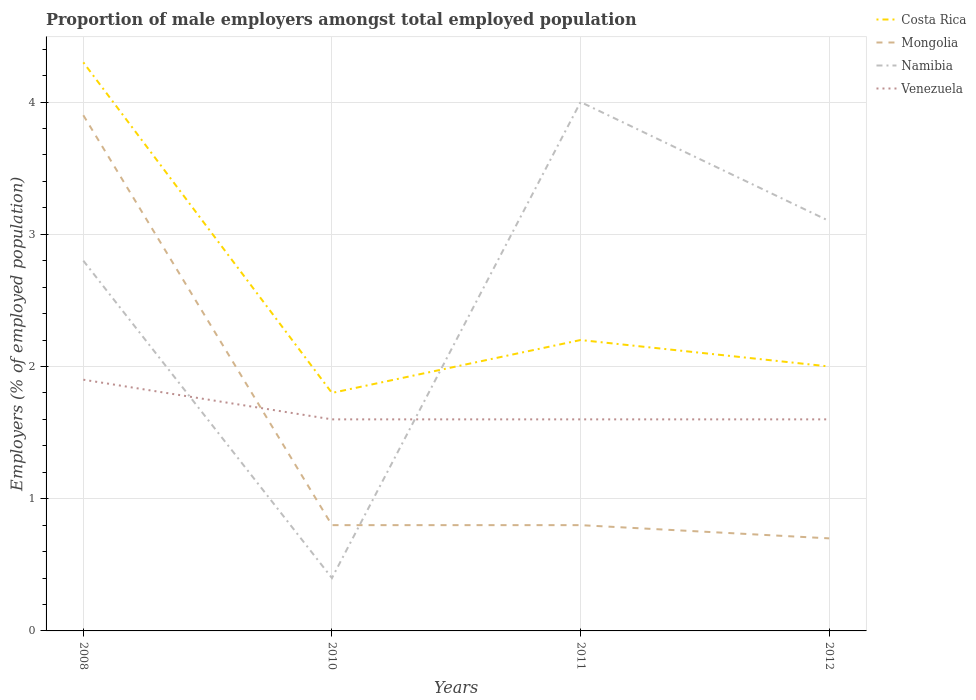Across all years, what is the maximum proportion of male employers in Venezuela?
Keep it short and to the point. 1.6. What is the total proportion of male employers in Costa Rica in the graph?
Provide a short and direct response. -0.4. What is the difference between the highest and the second highest proportion of male employers in Namibia?
Make the answer very short. 3.6. Is the proportion of male employers in Namibia strictly greater than the proportion of male employers in Costa Rica over the years?
Make the answer very short. No. How many lines are there?
Your answer should be compact. 4. What is the difference between two consecutive major ticks on the Y-axis?
Give a very brief answer. 1. Does the graph contain any zero values?
Keep it short and to the point. No. Does the graph contain grids?
Your answer should be compact. Yes. Where does the legend appear in the graph?
Provide a short and direct response. Top right. How are the legend labels stacked?
Provide a short and direct response. Vertical. What is the title of the graph?
Your answer should be very brief. Proportion of male employers amongst total employed population. What is the label or title of the Y-axis?
Ensure brevity in your answer.  Employers (% of employed population). What is the Employers (% of employed population) of Costa Rica in 2008?
Your answer should be very brief. 4.3. What is the Employers (% of employed population) in Mongolia in 2008?
Keep it short and to the point. 3.9. What is the Employers (% of employed population) in Namibia in 2008?
Keep it short and to the point. 2.8. What is the Employers (% of employed population) in Venezuela in 2008?
Your answer should be compact. 1.9. What is the Employers (% of employed population) in Costa Rica in 2010?
Keep it short and to the point. 1.8. What is the Employers (% of employed population) in Mongolia in 2010?
Offer a terse response. 0.8. What is the Employers (% of employed population) in Namibia in 2010?
Offer a terse response. 0.4. What is the Employers (% of employed population) of Venezuela in 2010?
Your response must be concise. 1.6. What is the Employers (% of employed population) in Costa Rica in 2011?
Offer a very short reply. 2.2. What is the Employers (% of employed population) of Mongolia in 2011?
Offer a very short reply. 0.8. What is the Employers (% of employed population) in Namibia in 2011?
Give a very brief answer. 4. What is the Employers (% of employed population) of Venezuela in 2011?
Provide a short and direct response. 1.6. What is the Employers (% of employed population) in Mongolia in 2012?
Keep it short and to the point. 0.7. What is the Employers (% of employed population) of Namibia in 2012?
Your response must be concise. 3.1. What is the Employers (% of employed population) in Venezuela in 2012?
Provide a short and direct response. 1.6. Across all years, what is the maximum Employers (% of employed population) of Costa Rica?
Offer a terse response. 4.3. Across all years, what is the maximum Employers (% of employed population) in Mongolia?
Your answer should be very brief. 3.9. Across all years, what is the maximum Employers (% of employed population) in Venezuela?
Provide a short and direct response. 1.9. Across all years, what is the minimum Employers (% of employed population) of Costa Rica?
Your answer should be very brief. 1.8. Across all years, what is the minimum Employers (% of employed population) in Mongolia?
Offer a terse response. 0.7. Across all years, what is the minimum Employers (% of employed population) in Namibia?
Ensure brevity in your answer.  0.4. Across all years, what is the minimum Employers (% of employed population) in Venezuela?
Your answer should be very brief. 1.6. What is the total Employers (% of employed population) of Mongolia in the graph?
Your answer should be compact. 6.2. What is the total Employers (% of employed population) in Venezuela in the graph?
Offer a very short reply. 6.7. What is the difference between the Employers (% of employed population) in Costa Rica in 2008 and that in 2010?
Offer a very short reply. 2.5. What is the difference between the Employers (% of employed population) of Mongolia in 2008 and that in 2010?
Provide a short and direct response. 3.1. What is the difference between the Employers (% of employed population) in Namibia in 2008 and that in 2010?
Keep it short and to the point. 2.4. What is the difference between the Employers (% of employed population) of Namibia in 2008 and that in 2011?
Your response must be concise. -1.2. What is the difference between the Employers (% of employed population) in Venezuela in 2008 and that in 2011?
Offer a terse response. 0.3. What is the difference between the Employers (% of employed population) of Costa Rica in 2010 and that in 2011?
Keep it short and to the point. -0.4. What is the difference between the Employers (% of employed population) in Namibia in 2010 and that in 2011?
Your answer should be compact. -3.6. What is the difference between the Employers (% of employed population) in Venezuela in 2010 and that in 2011?
Keep it short and to the point. 0. What is the difference between the Employers (% of employed population) in Mongolia in 2010 and that in 2012?
Provide a succinct answer. 0.1. What is the difference between the Employers (% of employed population) in Costa Rica in 2011 and that in 2012?
Offer a terse response. 0.2. What is the difference between the Employers (% of employed population) in Mongolia in 2011 and that in 2012?
Make the answer very short. 0.1. What is the difference between the Employers (% of employed population) in Costa Rica in 2008 and the Employers (% of employed population) in Mongolia in 2010?
Give a very brief answer. 3.5. What is the difference between the Employers (% of employed population) of Costa Rica in 2008 and the Employers (% of employed population) of Namibia in 2010?
Provide a short and direct response. 3.9. What is the difference between the Employers (% of employed population) of Namibia in 2008 and the Employers (% of employed population) of Venezuela in 2010?
Your answer should be compact. 1.2. What is the difference between the Employers (% of employed population) in Costa Rica in 2008 and the Employers (% of employed population) in Mongolia in 2011?
Make the answer very short. 3.5. What is the difference between the Employers (% of employed population) of Mongolia in 2008 and the Employers (% of employed population) of Namibia in 2011?
Give a very brief answer. -0.1. What is the difference between the Employers (% of employed population) of Costa Rica in 2008 and the Employers (% of employed population) of Mongolia in 2012?
Ensure brevity in your answer.  3.6. What is the difference between the Employers (% of employed population) of Mongolia in 2008 and the Employers (% of employed population) of Venezuela in 2012?
Provide a succinct answer. 2.3. What is the difference between the Employers (% of employed population) in Costa Rica in 2010 and the Employers (% of employed population) in Namibia in 2011?
Your response must be concise. -2.2. What is the difference between the Employers (% of employed population) of Mongolia in 2010 and the Employers (% of employed population) of Namibia in 2011?
Your answer should be very brief. -3.2. What is the difference between the Employers (% of employed population) in Namibia in 2010 and the Employers (% of employed population) in Venezuela in 2011?
Provide a short and direct response. -1.2. What is the difference between the Employers (% of employed population) of Costa Rica in 2010 and the Employers (% of employed population) of Mongolia in 2012?
Offer a very short reply. 1.1. What is the difference between the Employers (% of employed population) in Costa Rica in 2010 and the Employers (% of employed population) in Venezuela in 2012?
Your answer should be very brief. 0.2. What is the difference between the Employers (% of employed population) of Mongolia in 2010 and the Employers (% of employed population) of Namibia in 2012?
Offer a terse response. -2.3. What is the difference between the Employers (% of employed population) of Namibia in 2010 and the Employers (% of employed population) of Venezuela in 2012?
Offer a very short reply. -1.2. What is the difference between the Employers (% of employed population) of Costa Rica in 2011 and the Employers (% of employed population) of Mongolia in 2012?
Offer a very short reply. 1.5. What is the difference between the Employers (% of employed population) in Costa Rica in 2011 and the Employers (% of employed population) in Venezuela in 2012?
Your answer should be compact. 0.6. What is the average Employers (% of employed population) of Costa Rica per year?
Offer a very short reply. 2.58. What is the average Employers (% of employed population) of Mongolia per year?
Your response must be concise. 1.55. What is the average Employers (% of employed population) of Namibia per year?
Provide a short and direct response. 2.58. What is the average Employers (% of employed population) in Venezuela per year?
Offer a very short reply. 1.68. In the year 2008, what is the difference between the Employers (% of employed population) in Costa Rica and Employers (% of employed population) in Mongolia?
Your answer should be very brief. 0.4. In the year 2008, what is the difference between the Employers (% of employed population) in Costa Rica and Employers (% of employed population) in Venezuela?
Provide a succinct answer. 2.4. In the year 2008, what is the difference between the Employers (% of employed population) of Mongolia and Employers (% of employed population) of Namibia?
Your answer should be compact. 1.1. In the year 2008, what is the difference between the Employers (% of employed population) in Mongolia and Employers (% of employed population) in Venezuela?
Provide a succinct answer. 2. In the year 2008, what is the difference between the Employers (% of employed population) in Namibia and Employers (% of employed population) in Venezuela?
Offer a very short reply. 0.9. In the year 2010, what is the difference between the Employers (% of employed population) of Costa Rica and Employers (% of employed population) of Mongolia?
Your answer should be very brief. 1. In the year 2010, what is the difference between the Employers (% of employed population) in Costa Rica and Employers (% of employed population) in Venezuela?
Keep it short and to the point. 0.2. In the year 2010, what is the difference between the Employers (% of employed population) of Mongolia and Employers (% of employed population) of Venezuela?
Keep it short and to the point. -0.8. In the year 2011, what is the difference between the Employers (% of employed population) in Costa Rica and Employers (% of employed population) in Venezuela?
Make the answer very short. 0.6. In the year 2011, what is the difference between the Employers (% of employed population) of Mongolia and Employers (% of employed population) of Namibia?
Provide a succinct answer. -3.2. In the year 2012, what is the difference between the Employers (% of employed population) in Costa Rica and Employers (% of employed population) in Mongolia?
Provide a short and direct response. 1.3. In the year 2012, what is the difference between the Employers (% of employed population) in Mongolia and Employers (% of employed population) in Namibia?
Your answer should be compact. -2.4. In the year 2012, what is the difference between the Employers (% of employed population) of Mongolia and Employers (% of employed population) of Venezuela?
Your answer should be very brief. -0.9. In the year 2012, what is the difference between the Employers (% of employed population) in Namibia and Employers (% of employed population) in Venezuela?
Provide a succinct answer. 1.5. What is the ratio of the Employers (% of employed population) in Costa Rica in 2008 to that in 2010?
Your answer should be compact. 2.39. What is the ratio of the Employers (% of employed population) of Mongolia in 2008 to that in 2010?
Ensure brevity in your answer.  4.88. What is the ratio of the Employers (% of employed population) in Venezuela in 2008 to that in 2010?
Your answer should be very brief. 1.19. What is the ratio of the Employers (% of employed population) in Costa Rica in 2008 to that in 2011?
Offer a terse response. 1.95. What is the ratio of the Employers (% of employed population) of Mongolia in 2008 to that in 2011?
Your answer should be very brief. 4.88. What is the ratio of the Employers (% of employed population) in Venezuela in 2008 to that in 2011?
Provide a short and direct response. 1.19. What is the ratio of the Employers (% of employed population) of Costa Rica in 2008 to that in 2012?
Ensure brevity in your answer.  2.15. What is the ratio of the Employers (% of employed population) in Mongolia in 2008 to that in 2012?
Provide a succinct answer. 5.57. What is the ratio of the Employers (% of employed population) of Namibia in 2008 to that in 2012?
Ensure brevity in your answer.  0.9. What is the ratio of the Employers (% of employed population) in Venezuela in 2008 to that in 2012?
Provide a short and direct response. 1.19. What is the ratio of the Employers (% of employed population) of Costa Rica in 2010 to that in 2011?
Your answer should be very brief. 0.82. What is the ratio of the Employers (% of employed population) of Mongolia in 2010 to that in 2011?
Provide a succinct answer. 1. What is the ratio of the Employers (% of employed population) in Venezuela in 2010 to that in 2011?
Provide a succinct answer. 1. What is the ratio of the Employers (% of employed population) of Costa Rica in 2010 to that in 2012?
Give a very brief answer. 0.9. What is the ratio of the Employers (% of employed population) of Namibia in 2010 to that in 2012?
Provide a succinct answer. 0.13. What is the ratio of the Employers (% of employed population) of Costa Rica in 2011 to that in 2012?
Offer a terse response. 1.1. What is the ratio of the Employers (% of employed population) in Mongolia in 2011 to that in 2012?
Your answer should be very brief. 1.14. What is the ratio of the Employers (% of employed population) in Namibia in 2011 to that in 2012?
Provide a succinct answer. 1.29. What is the difference between the highest and the second highest Employers (% of employed population) of Venezuela?
Give a very brief answer. 0.3. What is the difference between the highest and the lowest Employers (% of employed population) in Costa Rica?
Your answer should be very brief. 2.5. What is the difference between the highest and the lowest Employers (% of employed population) in Venezuela?
Your answer should be very brief. 0.3. 